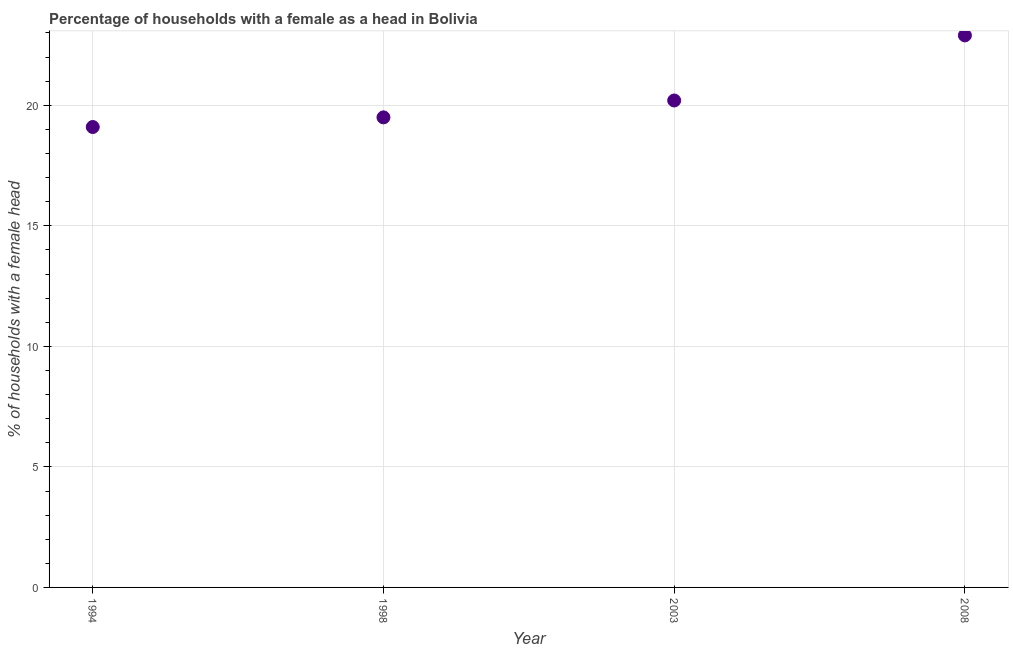What is the number of female supervised households in 2008?
Provide a short and direct response. 22.9. Across all years, what is the maximum number of female supervised households?
Your answer should be compact. 22.9. Across all years, what is the minimum number of female supervised households?
Your response must be concise. 19.1. What is the sum of the number of female supervised households?
Your response must be concise. 81.7. What is the difference between the number of female supervised households in 1994 and 2008?
Give a very brief answer. -3.8. What is the average number of female supervised households per year?
Make the answer very short. 20.42. What is the median number of female supervised households?
Offer a very short reply. 19.85. In how many years, is the number of female supervised households greater than 13 %?
Offer a very short reply. 4. Do a majority of the years between 2003 and 2008 (inclusive) have number of female supervised households greater than 16 %?
Make the answer very short. Yes. What is the ratio of the number of female supervised households in 1998 to that in 2008?
Your response must be concise. 0.85. What is the difference between the highest and the second highest number of female supervised households?
Your response must be concise. 2.7. Is the sum of the number of female supervised households in 2003 and 2008 greater than the maximum number of female supervised households across all years?
Keep it short and to the point. Yes. What is the difference between the highest and the lowest number of female supervised households?
Keep it short and to the point. 3.8. In how many years, is the number of female supervised households greater than the average number of female supervised households taken over all years?
Give a very brief answer. 1. Does the number of female supervised households monotonically increase over the years?
Provide a short and direct response. Yes. How many dotlines are there?
Make the answer very short. 1. What is the difference between two consecutive major ticks on the Y-axis?
Make the answer very short. 5. Does the graph contain any zero values?
Offer a terse response. No. What is the title of the graph?
Your answer should be very brief. Percentage of households with a female as a head in Bolivia. What is the label or title of the X-axis?
Provide a succinct answer. Year. What is the label or title of the Y-axis?
Make the answer very short. % of households with a female head. What is the % of households with a female head in 2003?
Offer a very short reply. 20.2. What is the % of households with a female head in 2008?
Your response must be concise. 22.9. What is the difference between the % of households with a female head in 1994 and 2003?
Keep it short and to the point. -1.1. What is the difference between the % of households with a female head in 1998 and 2003?
Your response must be concise. -0.7. What is the difference between the % of households with a female head in 1998 and 2008?
Keep it short and to the point. -3.4. What is the ratio of the % of households with a female head in 1994 to that in 2003?
Provide a short and direct response. 0.95. What is the ratio of the % of households with a female head in 1994 to that in 2008?
Make the answer very short. 0.83. What is the ratio of the % of households with a female head in 1998 to that in 2003?
Ensure brevity in your answer.  0.96. What is the ratio of the % of households with a female head in 1998 to that in 2008?
Provide a short and direct response. 0.85. What is the ratio of the % of households with a female head in 2003 to that in 2008?
Provide a succinct answer. 0.88. 